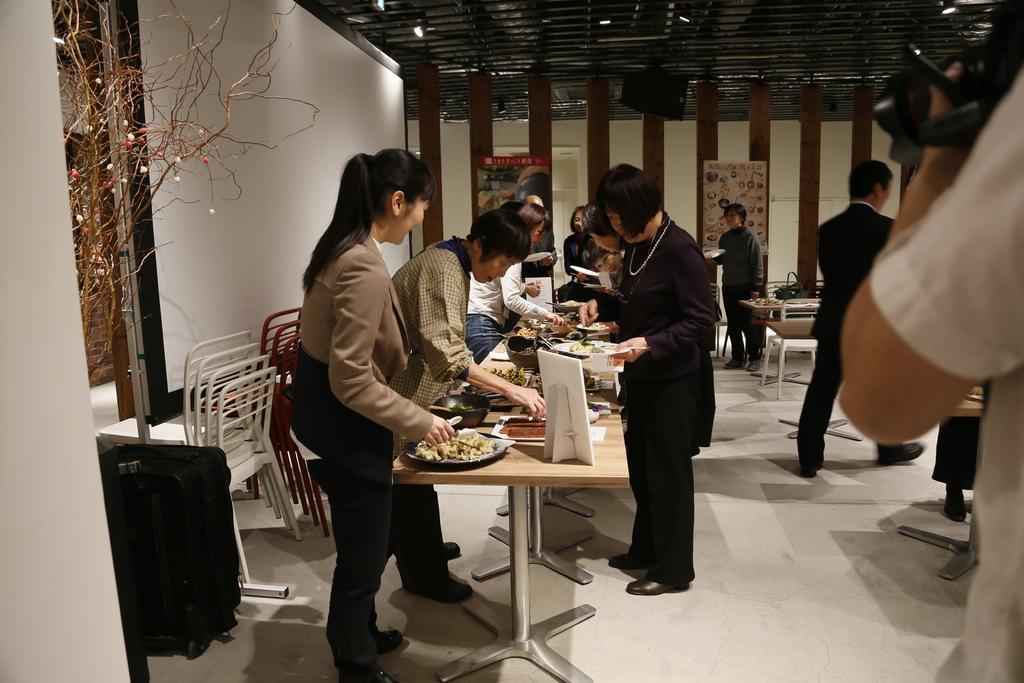Could you give a brief overview of what you see in this image? Here we can see some persons are standing on the floor. There are chairs and these are the tables. On the table there are plates, bowls, and some food. This is wall and there is a flower vase. Here we can see posters. This is roof and there is a light. 